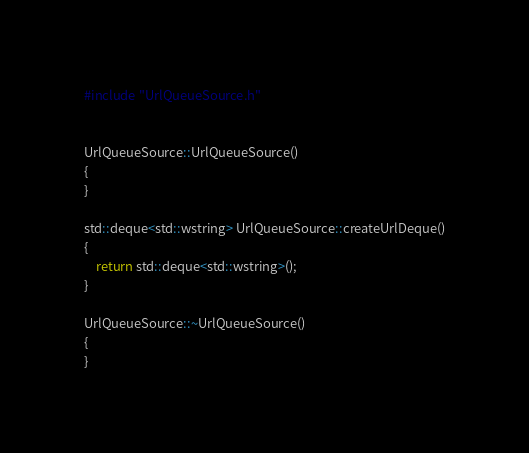<code> <loc_0><loc_0><loc_500><loc_500><_C++_>#include "UrlQueueSource.h"


UrlQueueSource::UrlQueueSource()
{
}

std::deque<std::wstring> UrlQueueSource::createUrlDeque()
{
	return std::deque<std::wstring>();
}

UrlQueueSource::~UrlQueueSource()
{
}
</code> 